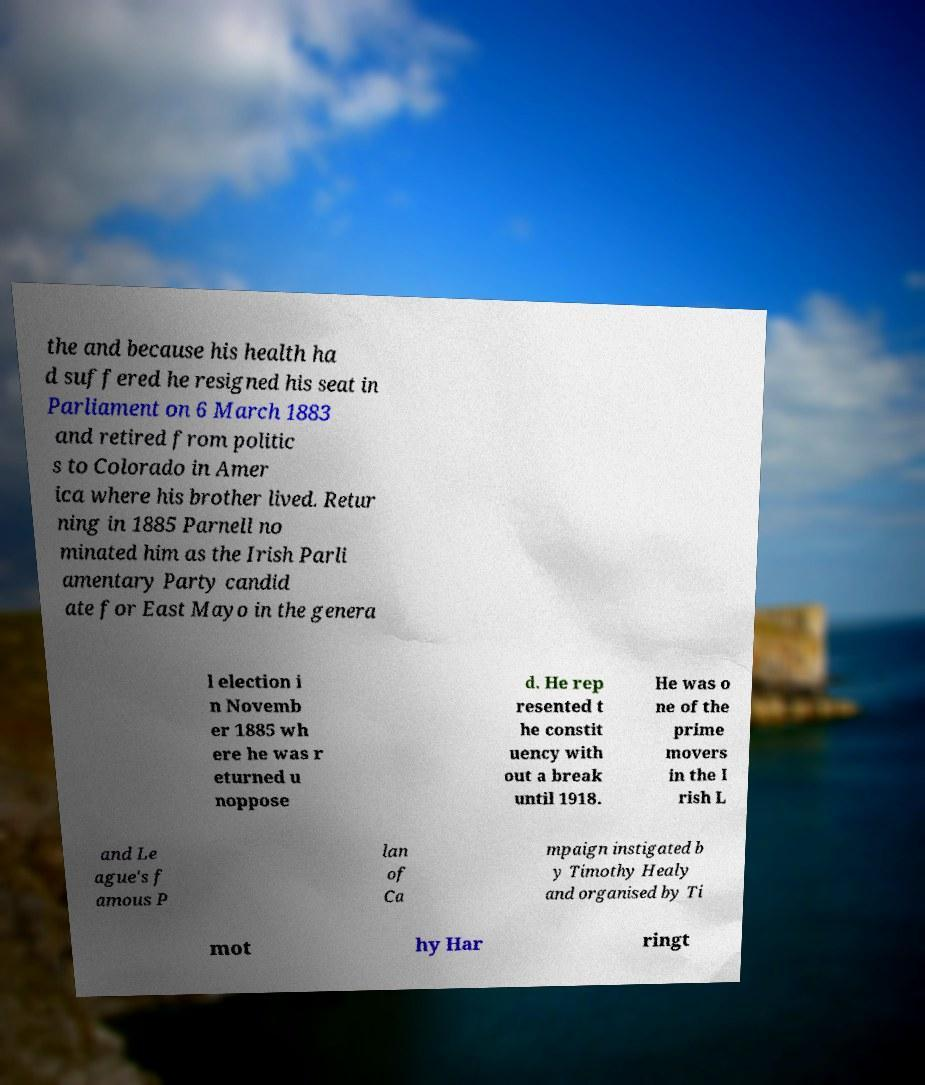Could you assist in decoding the text presented in this image and type it out clearly? the and because his health ha d suffered he resigned his seat in Parliament on 6 March 1883 and retired from politic s to Colorado in Amer ica where his brother lived. Retur ning in 1885 Parnell no minated him as the Irish Parli amentary Party candid ate for East Mayo in the genera l election i n Novemb er 1885 wh ere he was r eturned u noppose d. He rep resented t he constit uency with out a break until 1918. He was o ne of the prime movers in the I rish L and Le ague's f amous P lan of Ca mpaign instigated b y Timothy Healy and organised by Ti mot hy Har ringt 